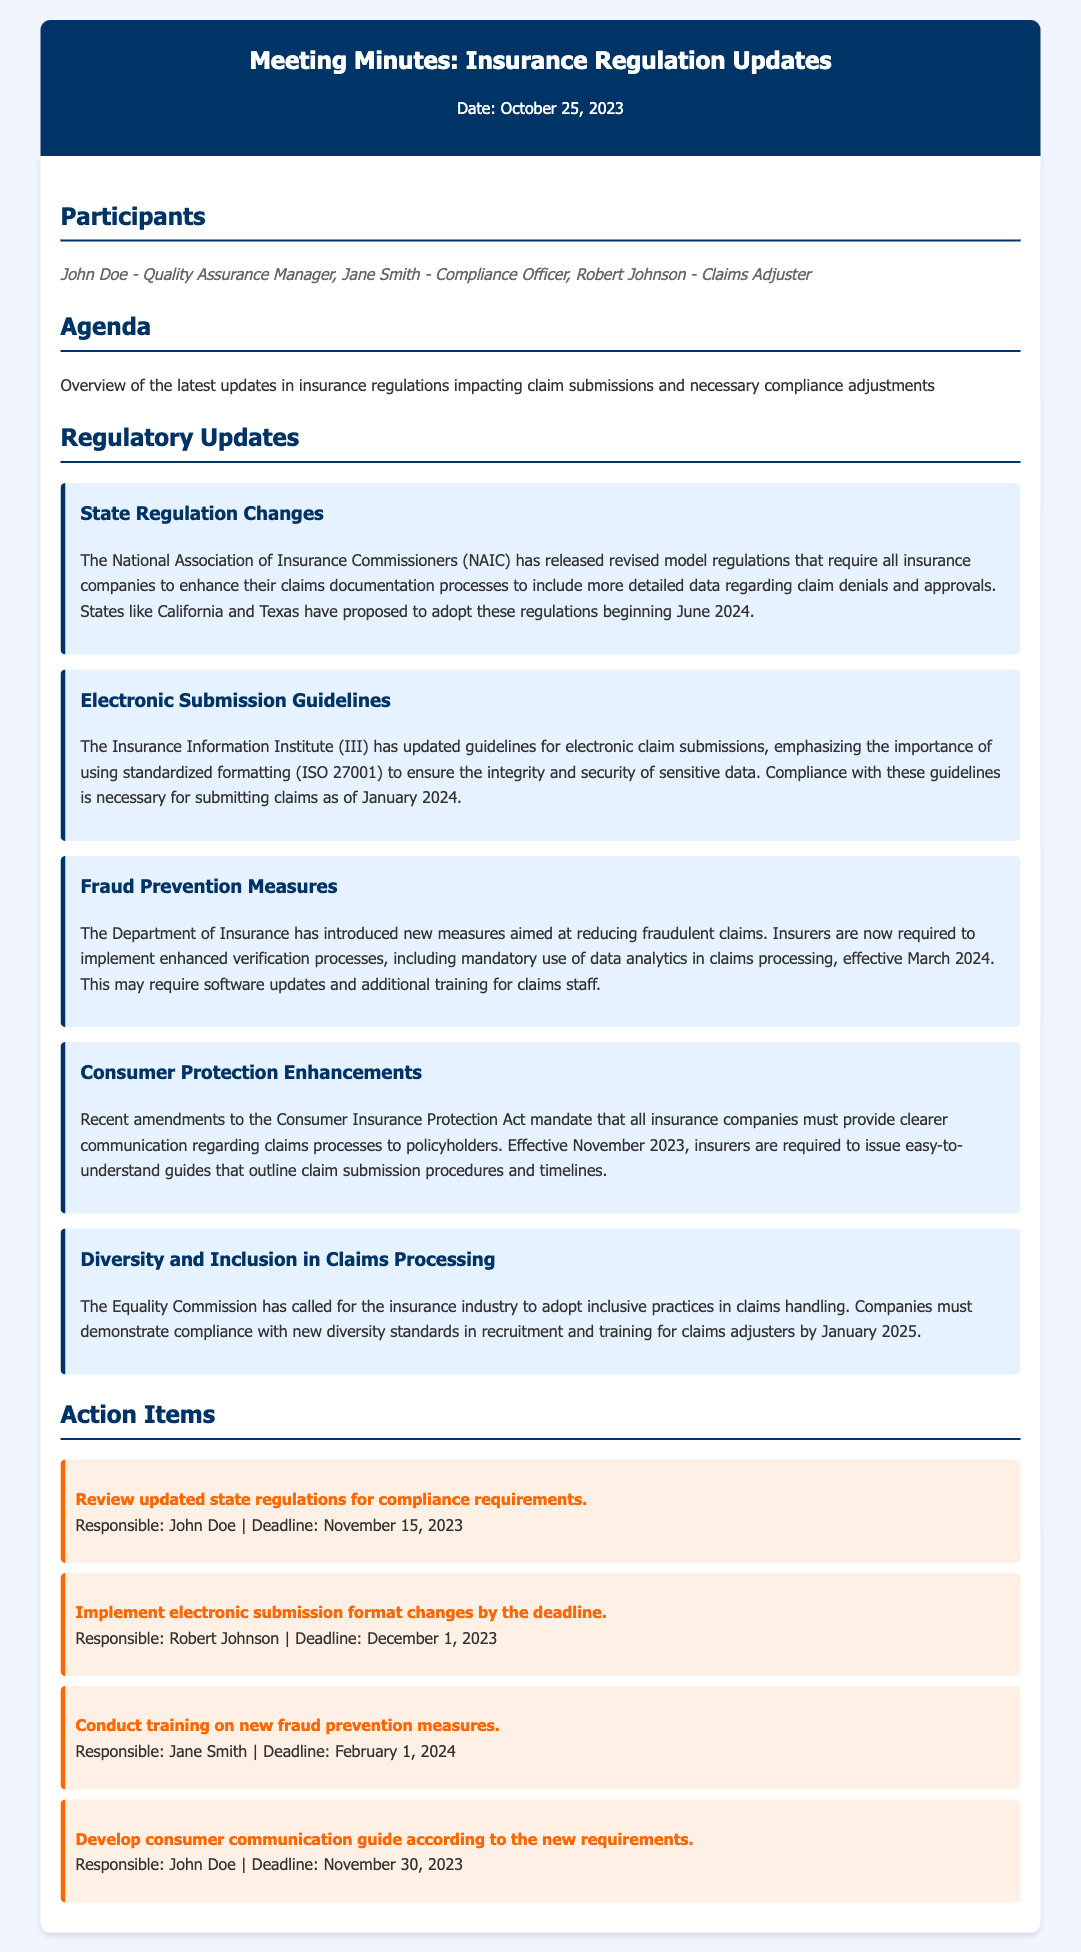What is the date of the meeting? The date of the meeting is provided in the document header.
Answer: October 25, 2023 Who is the Compliance Officer? The participants list in the document names each person and their role.
Answer: Jane Smith What are the new submission guidelines effective from January 2024? The regulatory updates section details the new guidelines relating to electronic submissions.
Answer: Standardized formatting (ISO 27001) What is the deadline for reviewing updated state regulations? The action items specify deadlines for each task.
Answer: November 15, 2023 What new requirement becomes effective in November 2023? The consumer protection enhancements section lists a specific amendment that will take effect.
Answer: Clearer communication regarding claims processes What is the main goal of the new fraud prevention measures? The update on fraud prevention summarizes the purpose of the measures introduced.
Answer: Reduce fraudulent claims Who is responsible for developing the consumer communication guide? The action items indicate who has been assigned to each task.
Answer: John Doe When must insurers demonstrate compliance with diversity standards? The diversity and inclusion update specifies a compliance deadline.
Answer: January 2025 What is the main regulatory body mentioned in the document? The document refers to this organization in the regulatory updates.
Answer: NAIC 